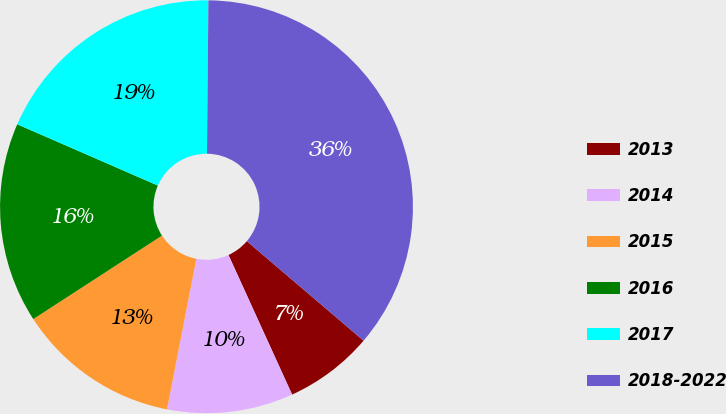Convert chart. <chart><loc_0><loc_0><loc_500><loc_500><pie_chart><fcel>2013<fcel>2014<fcel>2015<fcel>2016<fcel>2017<fcel>2018-2022<nl><fcel>6.96%<fcel>9.87%<fcel>12.78%<fcel>15.7%<fcel>18.61%<fcel>36.09%<nl></chart> 